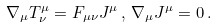<formula> <loc_0><loc_0><loc_500><loc_500>\nabla _ { \mu } T ^ { \mu } _ { \nu } = F _ { \mu \nu } J ^ { \mu } \, , \, \nabla _ { \mu } J ^ { \mu } = 0 \, .</formula> 